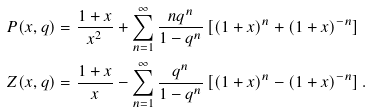Convert formula to latex. <formula><loc_0><loc_0><loc_500><loc_500>P ( x , q ) & = \frac { 1 + x } { x ^ { 2 } } + \sum _ { n = 1 } ^ { \infty } \frac { n q ^ { n } } { 1 - q ^ { n } } \left [ ( 1 + x ) ^ { n } + ( 1 + x ) ^ { - n } \right ] \\ Z ( x , q ) & = \frac { 1 + x } { x } - \sum _ { n = 1 } ^ { \infty } \frac { q ^ { n } } { 1 - q ^ { n } } \left [ ( 1 + x ) ^ { n } - ( 1 + x ) ^ { - n } \right ] .</formula> 